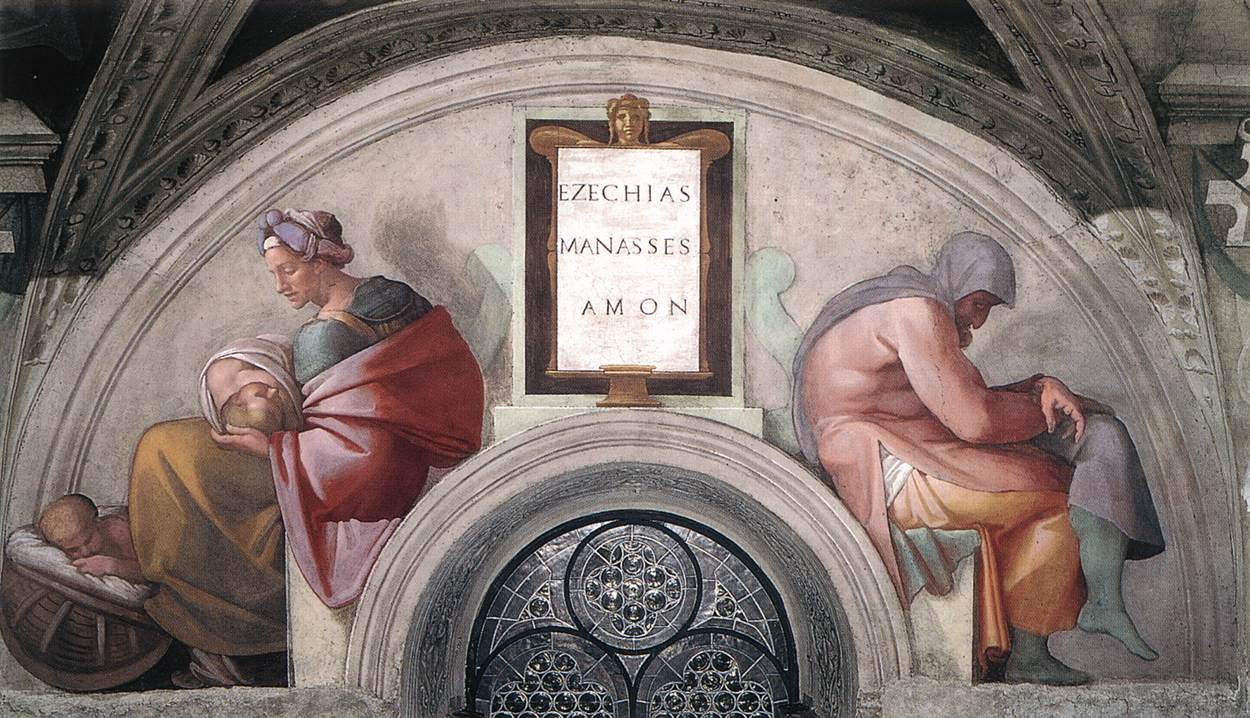What's happening in the scene? The image depicts a scene from an Italian Renaissance fresco, showcasing a tableau with significant biblical or mythological implications, possibly related to wisdom and legacy, as suggested by the plaque bearing the names 'Ezechias Manasses Amon', who are figures from the Bible noted for their varied legacies. The woman in the red robe, likely a central maternal figure, possibly symbolizes nurturing or caretaking, emphasizing a thematic focus on lineage and succession. The men flanking her could represent different aspects or periods of life, perhaps reflecting on the consequences of one's actions through generations. This artwork not only displays the refined Renaissance technique of perspective and architectural detail but also invites contemplation on deeper themes of life, legacy, and morality. 